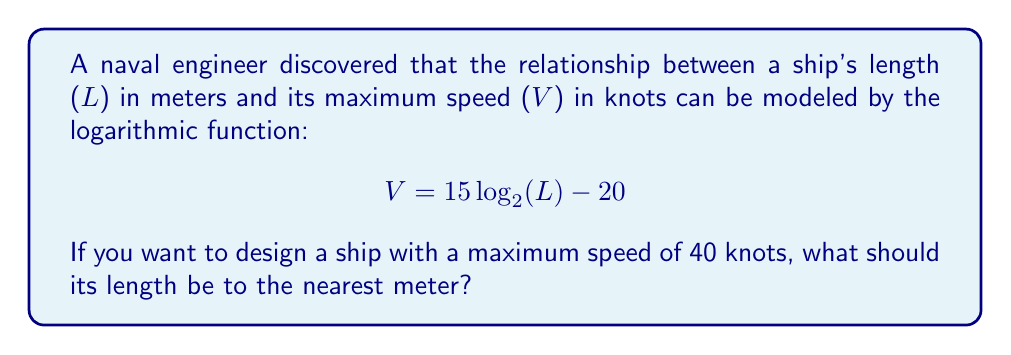What is the answer to this math problem? Let's approach this step-by-step:

1) We're given the function: $V = 15 \log_2(L) - 20$

2) We want to find $L$ when $V = 40$. Let's substitute this:

   $40 = 15 \log_2(L) - 20$

3) First, let's isolate the logarithmic term:
   
   $40 + 20 = 15 \log_2(L)$
   $60 = 15 \log_2(L)$

4) Now, divide both sides by 15:

   $\frac{60}{15} = \log_2(L)$
   $4 = \log_2(L)$

5) To solve for $L$, we need to apply the inverse function of $\log_2$, which is $2^x$:

   $2^4 = 2^{\log_2(L)}$
   $2^4 = L$

6) Calculate $2^4$:

   $L = 16$

Therefore, the ship's length should be 16 meters.
Answer: 16 meters 